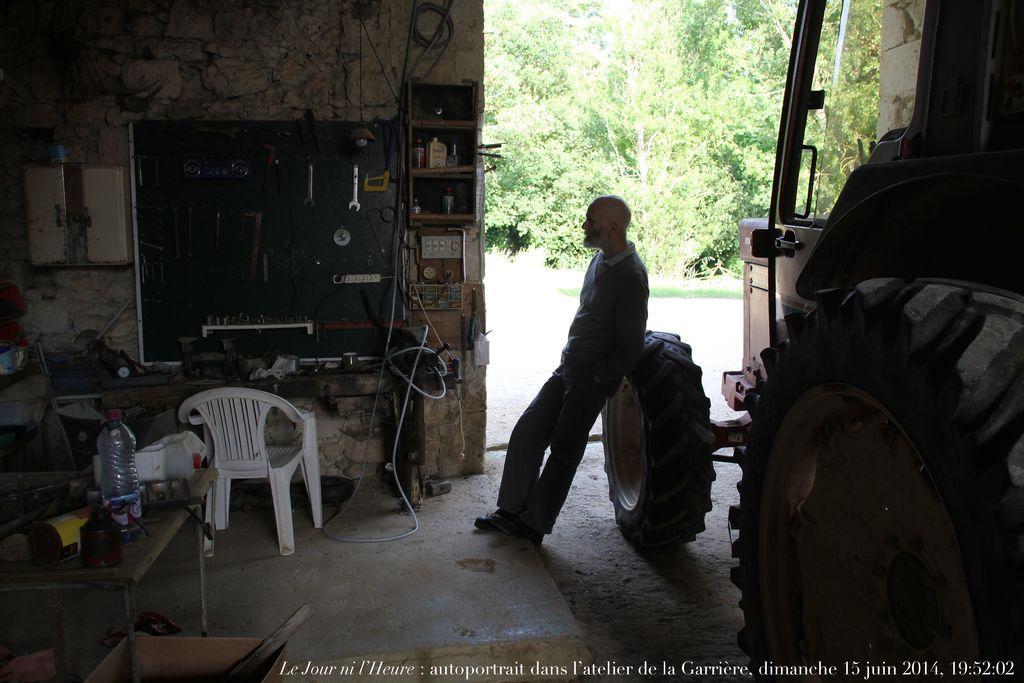Could you give a brief overview of what you see in this image? Here in the night we can see a vehicle present and man is leaning on the Tyre of the vehicle and we can see trees outside at the left side we can see a table and bottle present on it and there is a present and there are equipment mechanical equipments present 